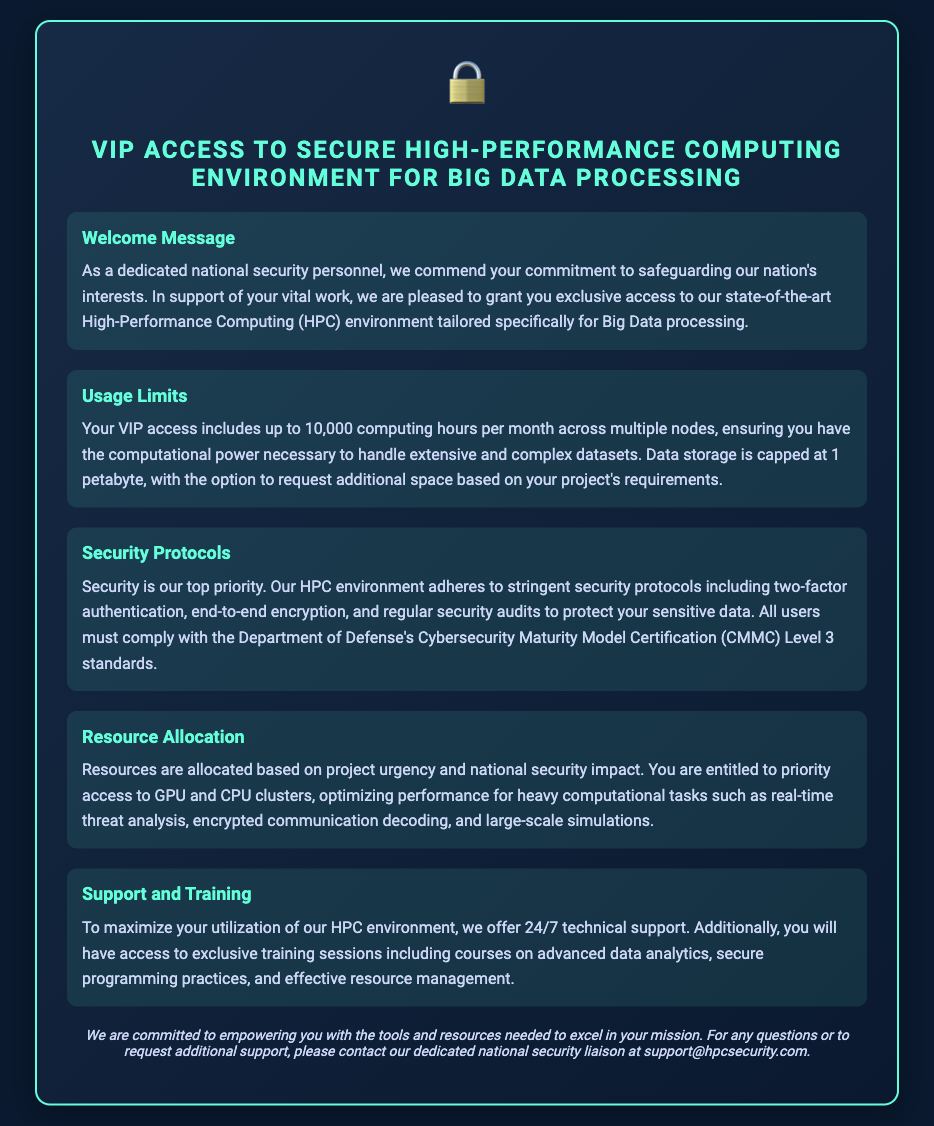What is the maximum number of computing hours per month? The document states that the VIP access includes up to 10,000 computing hours per month.
Answer: 10,000 What is the data storage limit? According to the document, data storage is capped at 1 petabyte.
Answer: 1 petabyte What security model compliance is required? The document specifies that all users must comply with the Department of Defense's Cybersecurity Maturity Model Certification (CMMC) Level 3 standards.
Answer: CMMC Level 3 What type of support is available 24/7? The document mentions that 24/7 technical support is offered to users.
Answer: Technical support What types of resources are prioritized? The document states that users are entitled to priority access to GPU and CPU clusters.
Answer: GPU and CPU clusters How can users request additional data storage? The document indicates that users can request additional space based on their project's requirements.
Answer: Request What additional training is offered? The document mentions access to exclusive training sessions including courses on advanced data analytics.
Answer: Advanced data analytics What is the primary focus of the welcome message? The welcome message commends the recipient's commitment to safeguarding the nation's interests.
Answer: Safeguarding the nation's interests What is the purpose of the HPC environment? The document highlights that the HPC environment is tailored specifically for Big Data processing.
Answer: Big Data processing 